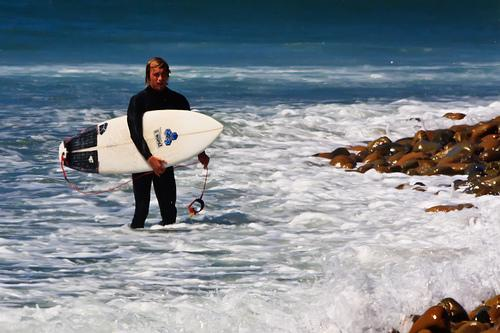What is one safety feature present in the image? A surfboard safety line, also known as a leg rope, is attached to the man's surfboard. Imagine you're selling this scene as a vacation destination. What are some appealing aspects you'd mention? Experience crystal blue ocean waves perfect for surfing, impressive rocky shores, and vibrant azure skies with cotton-like clouds. To show contrast, describe one detail about the appearance of the man in the image and one detail about the rocks. The man has blond wet hair, while the rocks in the image are brown and rugged. If this image was used for a surfer magazine cover, what could be a suitable headline? "Riding the Waves: Exploring the Thrill of Surfing Amidst Stunning Ocean Waves and Rocky Shores." List three features of the surrounding environment in the image. White clouds in blue sky, blue and white ocean waves, and brown rocks jutting into the sea. What is the man doing in the water, and what type of gear is he wearing? He is walking in the water while wearing a black wet suit and holding a white surfboard, which has a safety line attached. In an advertisement for a wet suit brand, mention a characteristic of the person wearing the wet suit in this image. Stay warm and stylish like this blonde-haired surfer wearing our sleek black wet suit while carrying his surfboard through the water. Characterize the man's appearance in the image. The man has blonde hair and is wearing a black wet suit while carrying a white surfboard. What is the main color of the surfboard the man is holding? The surfboard is predominantly white with some blue markings. Describe the texture and movement of the water in the image. Foamy surf in the background, ripples in the water, and white foam caused by crashing waves on the rocks. 